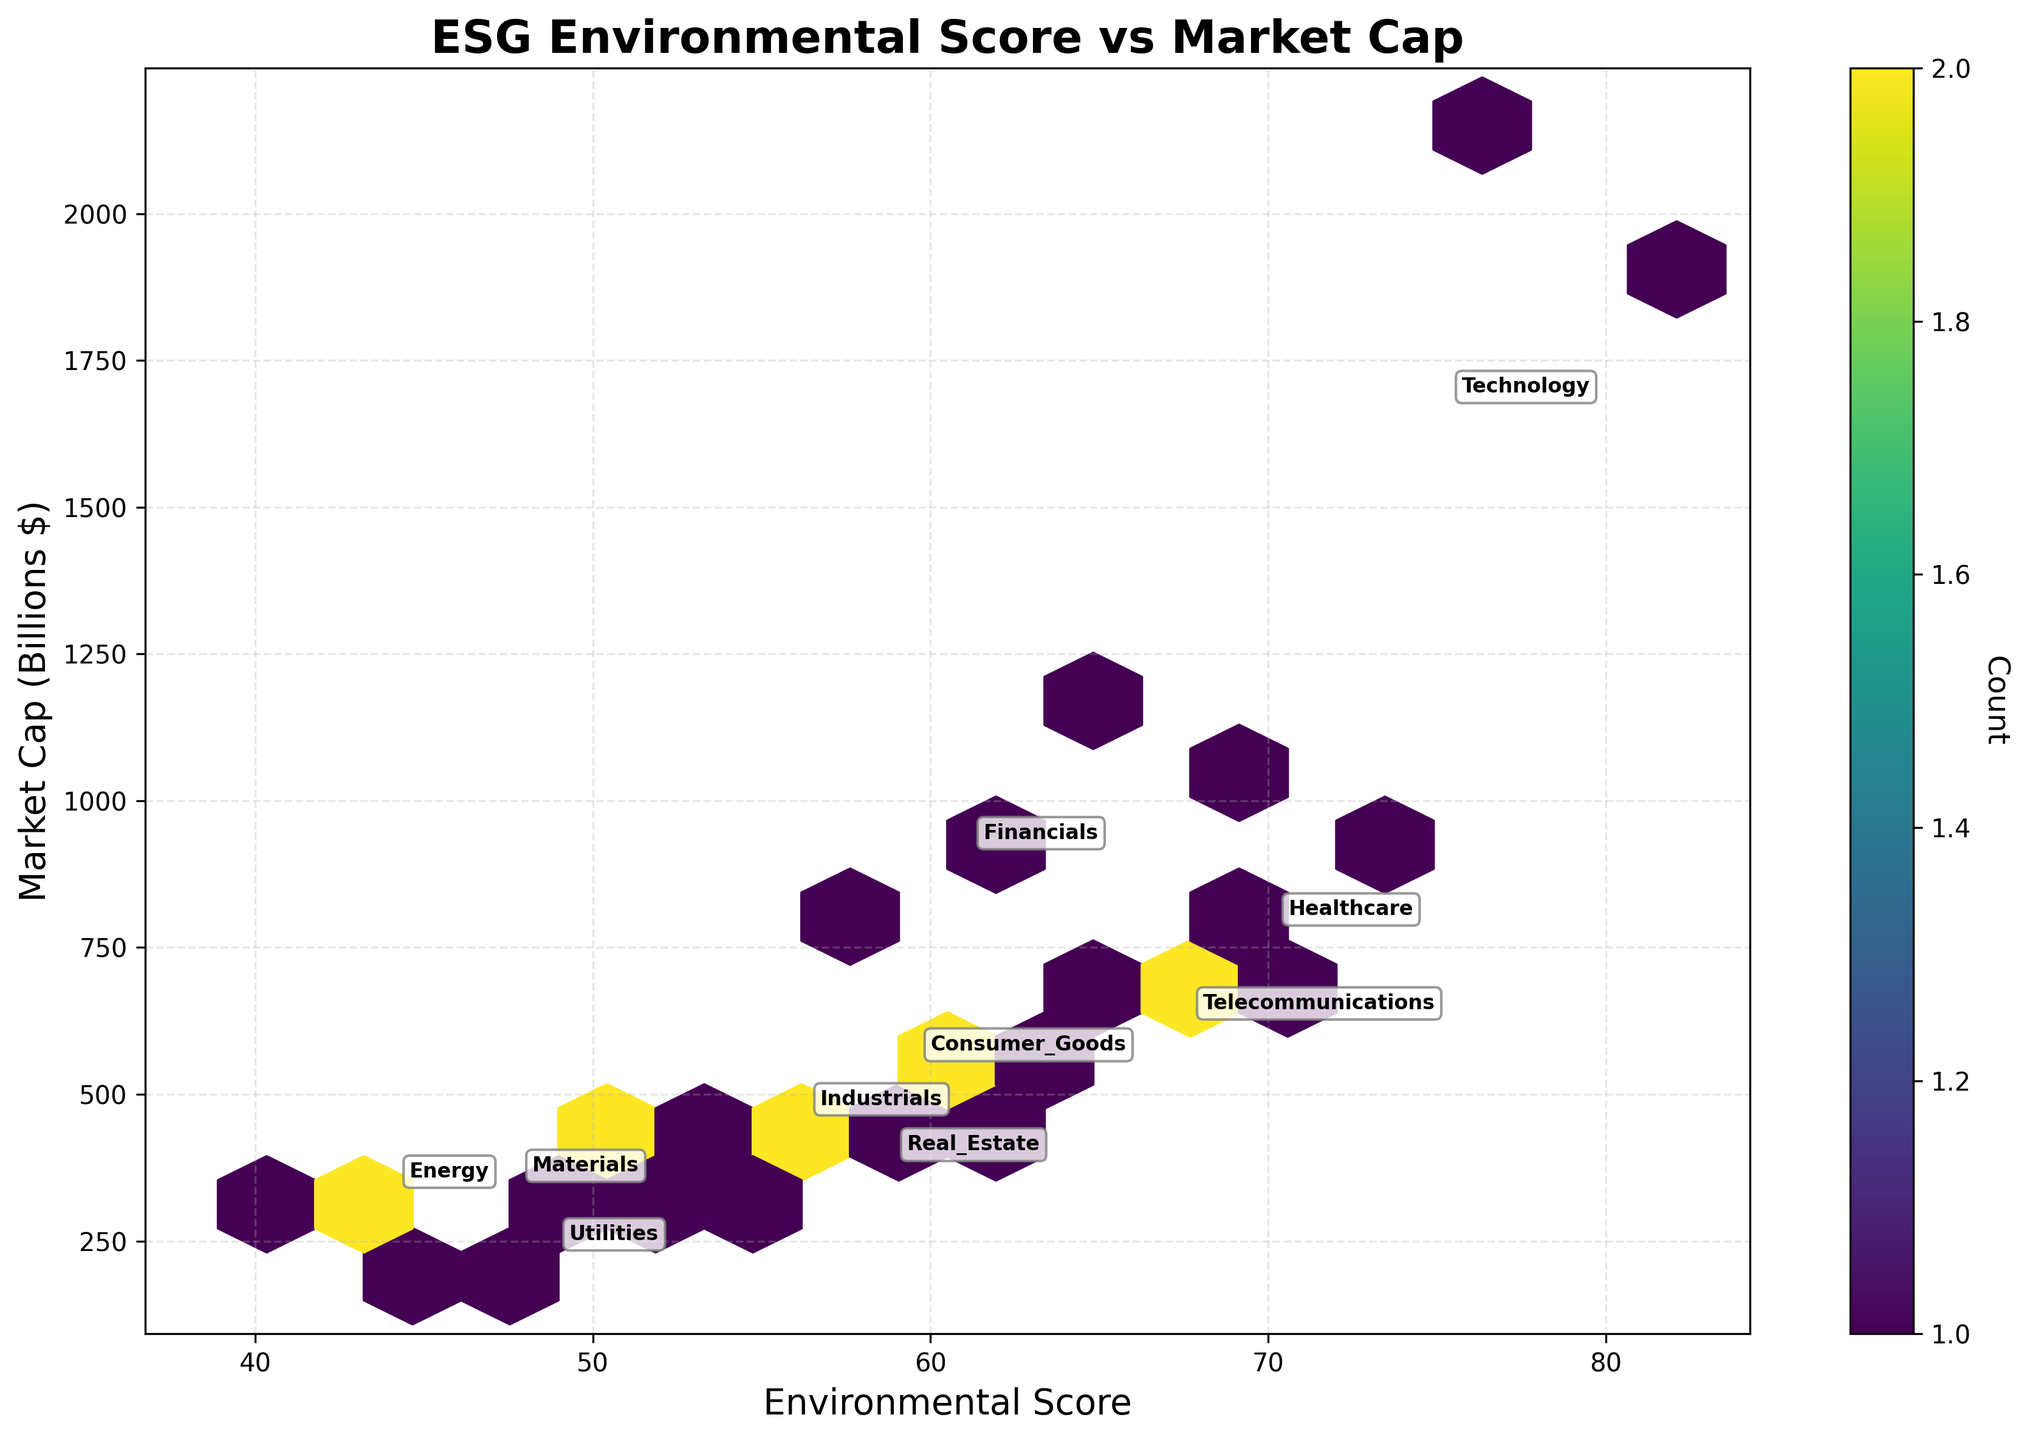What are the axes labels on the plot? The x-axis label is 'Environmental Score' and the y-axis label is 'Market Cap (Billions $)'.
Answer: 'Environmental Score' and 'Market Cap (Billions $)' What is the title of the plot? The title of the plot is "ESG Environmental Score vs Market Cap".
Answer: "ESG Environmental Score vs Market Cap" Which sector has the highest average Environmental Score on the plot? By looking at the annotated sectors, the Technology sector is annotated at a high Environmental Score on the plot.
Answer: Technology Which sector has the highest average Market Cap on the plot? According to the annotated sectors, the Technology sector has the highest average Market Cap.
Answer: Technology Which sector has the lowest average Environmental Score on the plot? The Energy sector is positioned the lowest in terms of Environmental Score based on the annotations.
Answer: Energy How many sectors have average Environmental Scores greater than 60? By observing the annotations, Technology, Healthcare, Telecommunications, and Financials sectors have average Environmental Scores above 60.
Answer: Four What is the average Environmental Score of the Consumer Goods sector approximately? The Consumer Goods sector is annotated around an Environmental Score slightly above 60.
Answer: Slightly above 60 Which sector shows the widest spread in Environmental Scores on the plot? The Technology sector exhibits the widest spread in Environmental Scores as evident from the multiple data points scattered across a larger range.
Answer: Technology Compare the average Market Cap between the Healthcare and Financials sectors. Which one is higher? Based on the annotations, the Financials sector has a higher average Market Cap compared to the Healthcare sector.
Answer: Financials How are colors used in the plot and what information do they convey? Colors in the plot represent the count of data points within each hexbin, with darker colors indicating a higher count.
Answer: Count of data points 